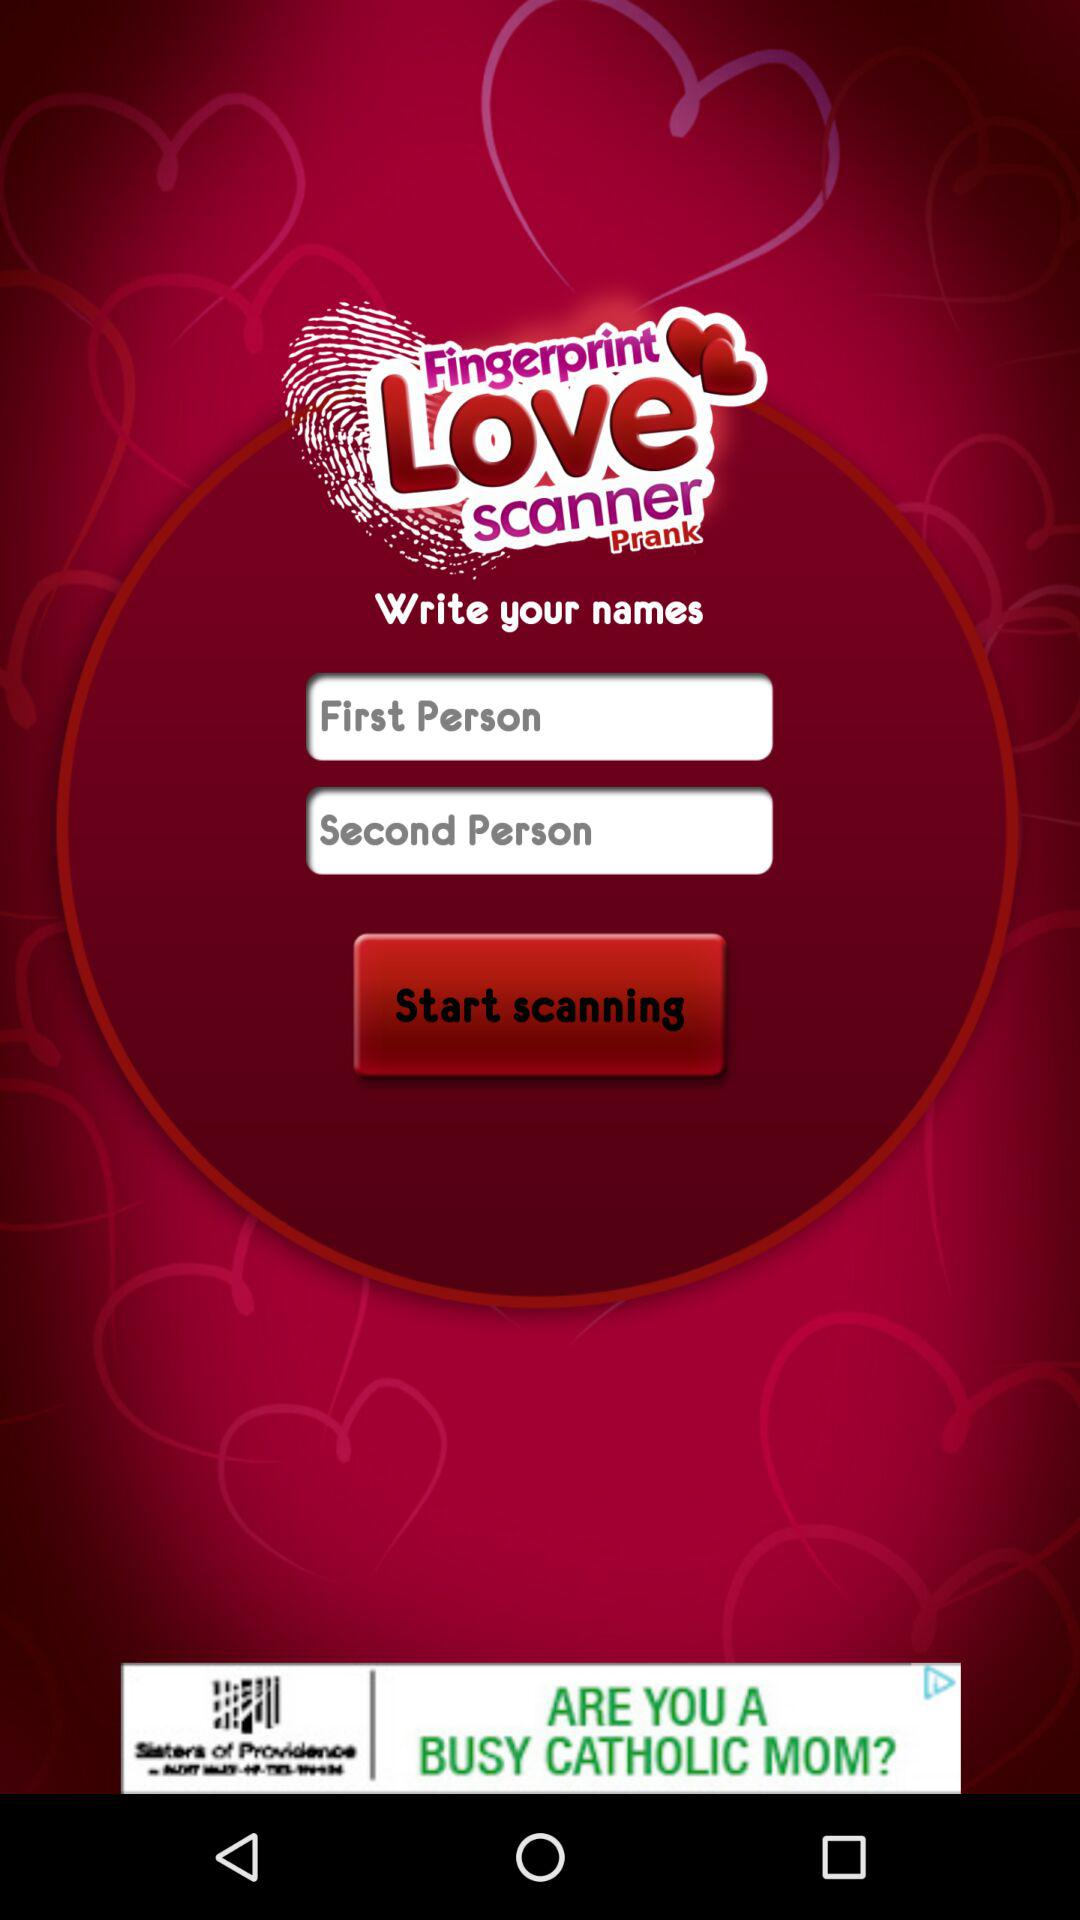How many text inputs are on the screen?
Answer the question using a single word or phrase. 2 